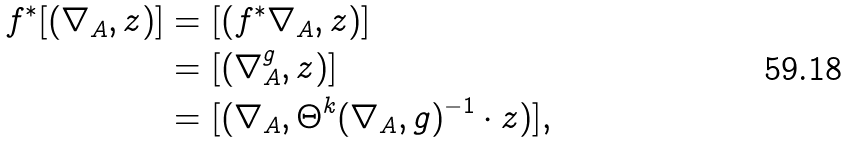Convert formula to latex. <formula><loc_0><loc_0><loc_500><loc_500>f ^ { * } [ ( \nabla _ { A } , z ) ] & = [ ( f ^ { * } \nabla _ { A } , z ) ] \\ & = [ ( \nabla _ { A } ^ { g } , z ) ] \\ & = [ ( \nabla _ { A } , \Theta ^ { k } ( \nabla _ { A } , g ) ^ { - 1 } \cdot z ) ] ,</formula> 